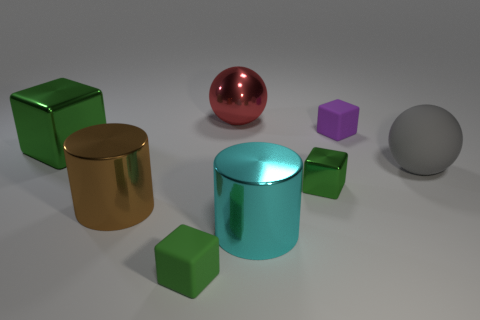Are there more green metal blocks that are behind the gray object than large red metallic spheres in front of the large metallic sphere?
Your answer should be compact. Yes. Is the size of the matte cube that is on the right side of the green matte thing the same as the big block?
Your answer should be compact. No. How many tiny blocks are to the left of the ball behind the rubber object that is behind the large gray object?
Your response must be concise. 1. What size is the object that is behind the big gray sphere and on the right side of the tiny metallic thing?
Ensure brevity in your answer.  Small. What number of other things are the same shape as the gray thing?
Make the answer very short. 1. How many large gray balls are right of the tiny shiny block?
Offer a terse response. 1. Is the number of green objects behind the gray object less than the number of green objects that are on the right side of the big brown cylinder?
Keep it short and to the point. Yes. The cyan thing that is in front of the large object behind the green metallic thing that is left of the cyan metal cylinder is what shape?
Keep it short and to the point. Cylinder. The object that is on the right side of the cyan shiny cylinder and behind the gray sphere has what shape?
Keep it short and to the point. Cube. Are there any other large things that have the same material as the brown object?
Your answer should be very brief. Yes. 